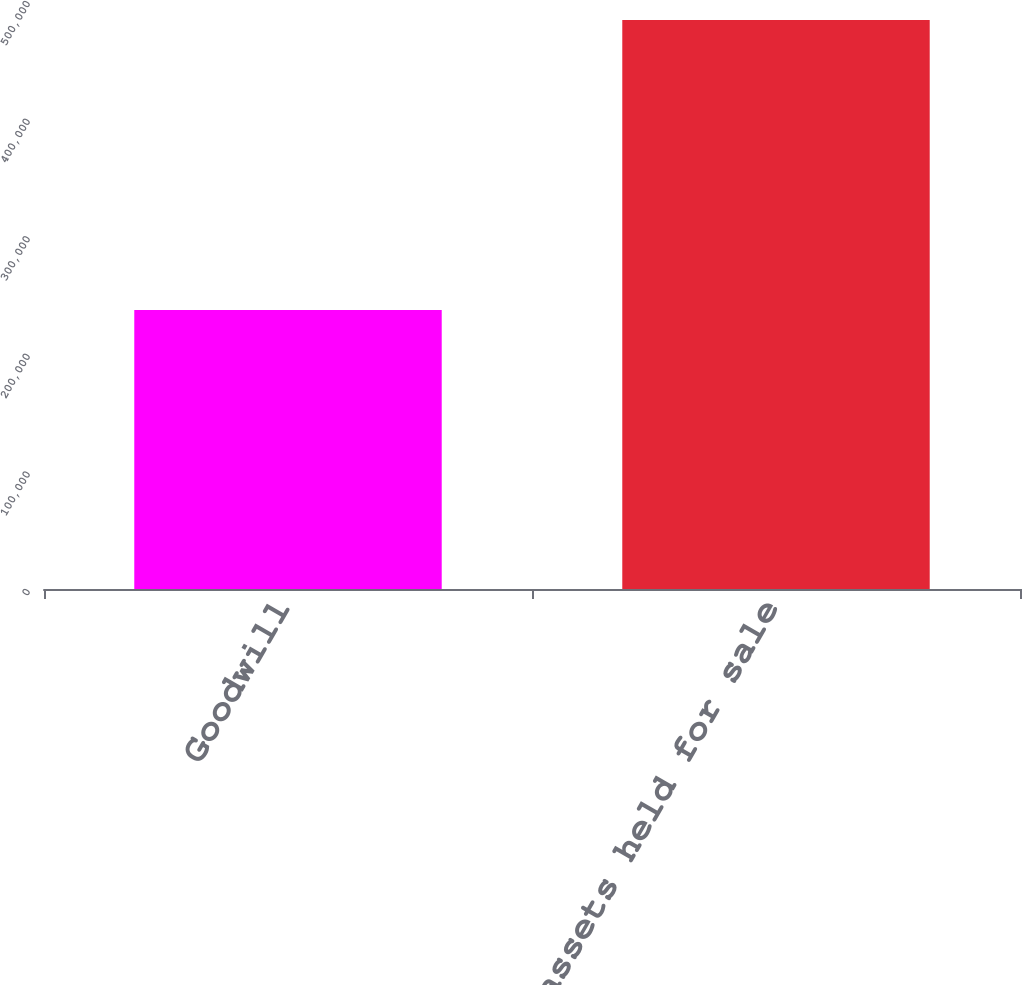<chart> <loc_0><loc_0><loc_500><loc_500><bar_chart><fcel>Goodwill<fcel>Total assets held for sale<nl><fcel>237177<fcel>483840<nl></chart> 